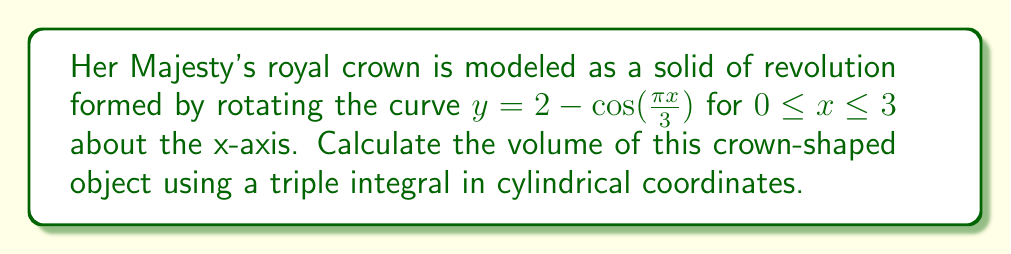Solve this math problem. To solve this problem, we'll follow these steps:

1) First, we need to set up the triple integral in cylindrical coordinates. The volume will be given by:

   $$V = \iiint_V r \, dr \, d\theta \, dz$$

2) Let's determine the limits of integration:
   - For $\theta$: The crown is a full revolution, so $0 \leq \theta \leq 2\pi$
   - For $r$: From the center to the surface of the crown, so $0 \leq r \leq 2 - \cos(\frac{\pi z}{3})$
   - For $z$: Along the height of the crown, so $0 \leq z \leq 3$

3) Our triple integral becomes:

   $$V = \int_0^3 \int_0^{2\pi} \int_0^{2 - \cos(\frac{\pi z}{3})} r \, dr \, d\theta \, dz$$

4) Let's solve the innermost integral first:

   $$\int_0^{2 - \cos(\frac{\pi z}{3})} r \, dr = \frac{1}{2}r^2 \bigg|_0^{2 - \cos(\frac{\pi z}{3})} = \frac{1}{2}(2 - \cos(\frac{\pi z}{3}))^2$$

5) Now our integral is:

   $$V = \int_0^3 \int_0^{2\pi} \frac{1}{2}(2 - \cos(\frac{\pi z}{3}))^2 \, d\theta \, dz$$

6) The $\theta$ integral is straightforward:

   $$\int_0^{2\pi} \frac{1}{2}(2 - \cos(\frac{\pi z}{3}))^2 \, d\theta = \pi(2 - \cos(\frac{\pi z}{3}))^2$$

7) Our final integral is:

   $$V = \pi \int_0^3 (2 - \cos(\frac{\pi z}{3}))^2 \, dz$$

8) Expand the squared term:

   $$V = \pi \int_0^3 (4 - 4\cos(\frac{\pi z}{3}) + \cos^2(\frac{\pi z}{3})) \, dz$$

9) Integrate term by term:

   $$V = \pi \left[4z - \frac{12}{\pi}\sin(\frac{\pi z}{3}) + \frac{3}{2}z + \frac{3}{4\pi}\sin(\frac{2\pi z}{3})\right]_0^3$$

10) Evaluate the limits:

    $$V = \pi \left[(12 - 0) - \frac{12}{\pi}(0 - 0) + (\frac{9}{2} - 0) + \frac{3}{4\pi}(0 - 0)\right]$$

11) Simplify:

    $$V = \pi(12 + \frac{9}{2}) = \frac{33\pi}{2}$$
Answer: $\frac{33\pi}{2}$ cubic units 